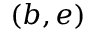<formula> <loc_0><loc_0><loc_500><loc_500>( b , e )</formula> 